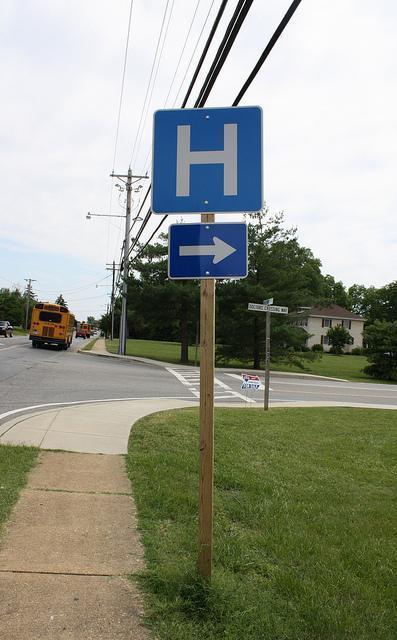How many dogs are in this picture?
Give a very brief answer. 0. How many women pictured?
Give a very brief answer. 0. 